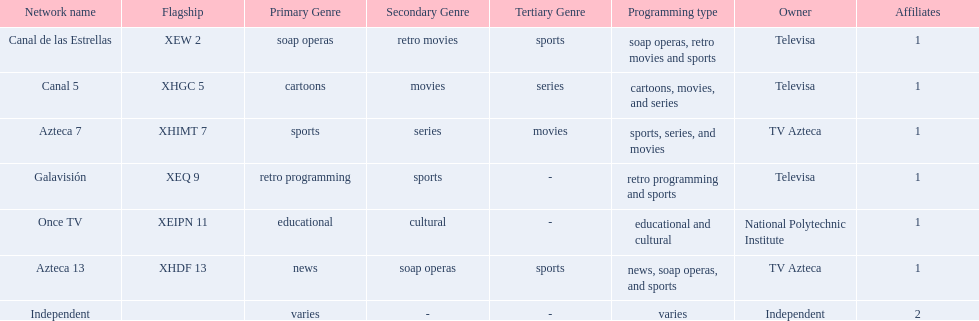What is the typical amount of affiliates a specific network possesses? 1. 